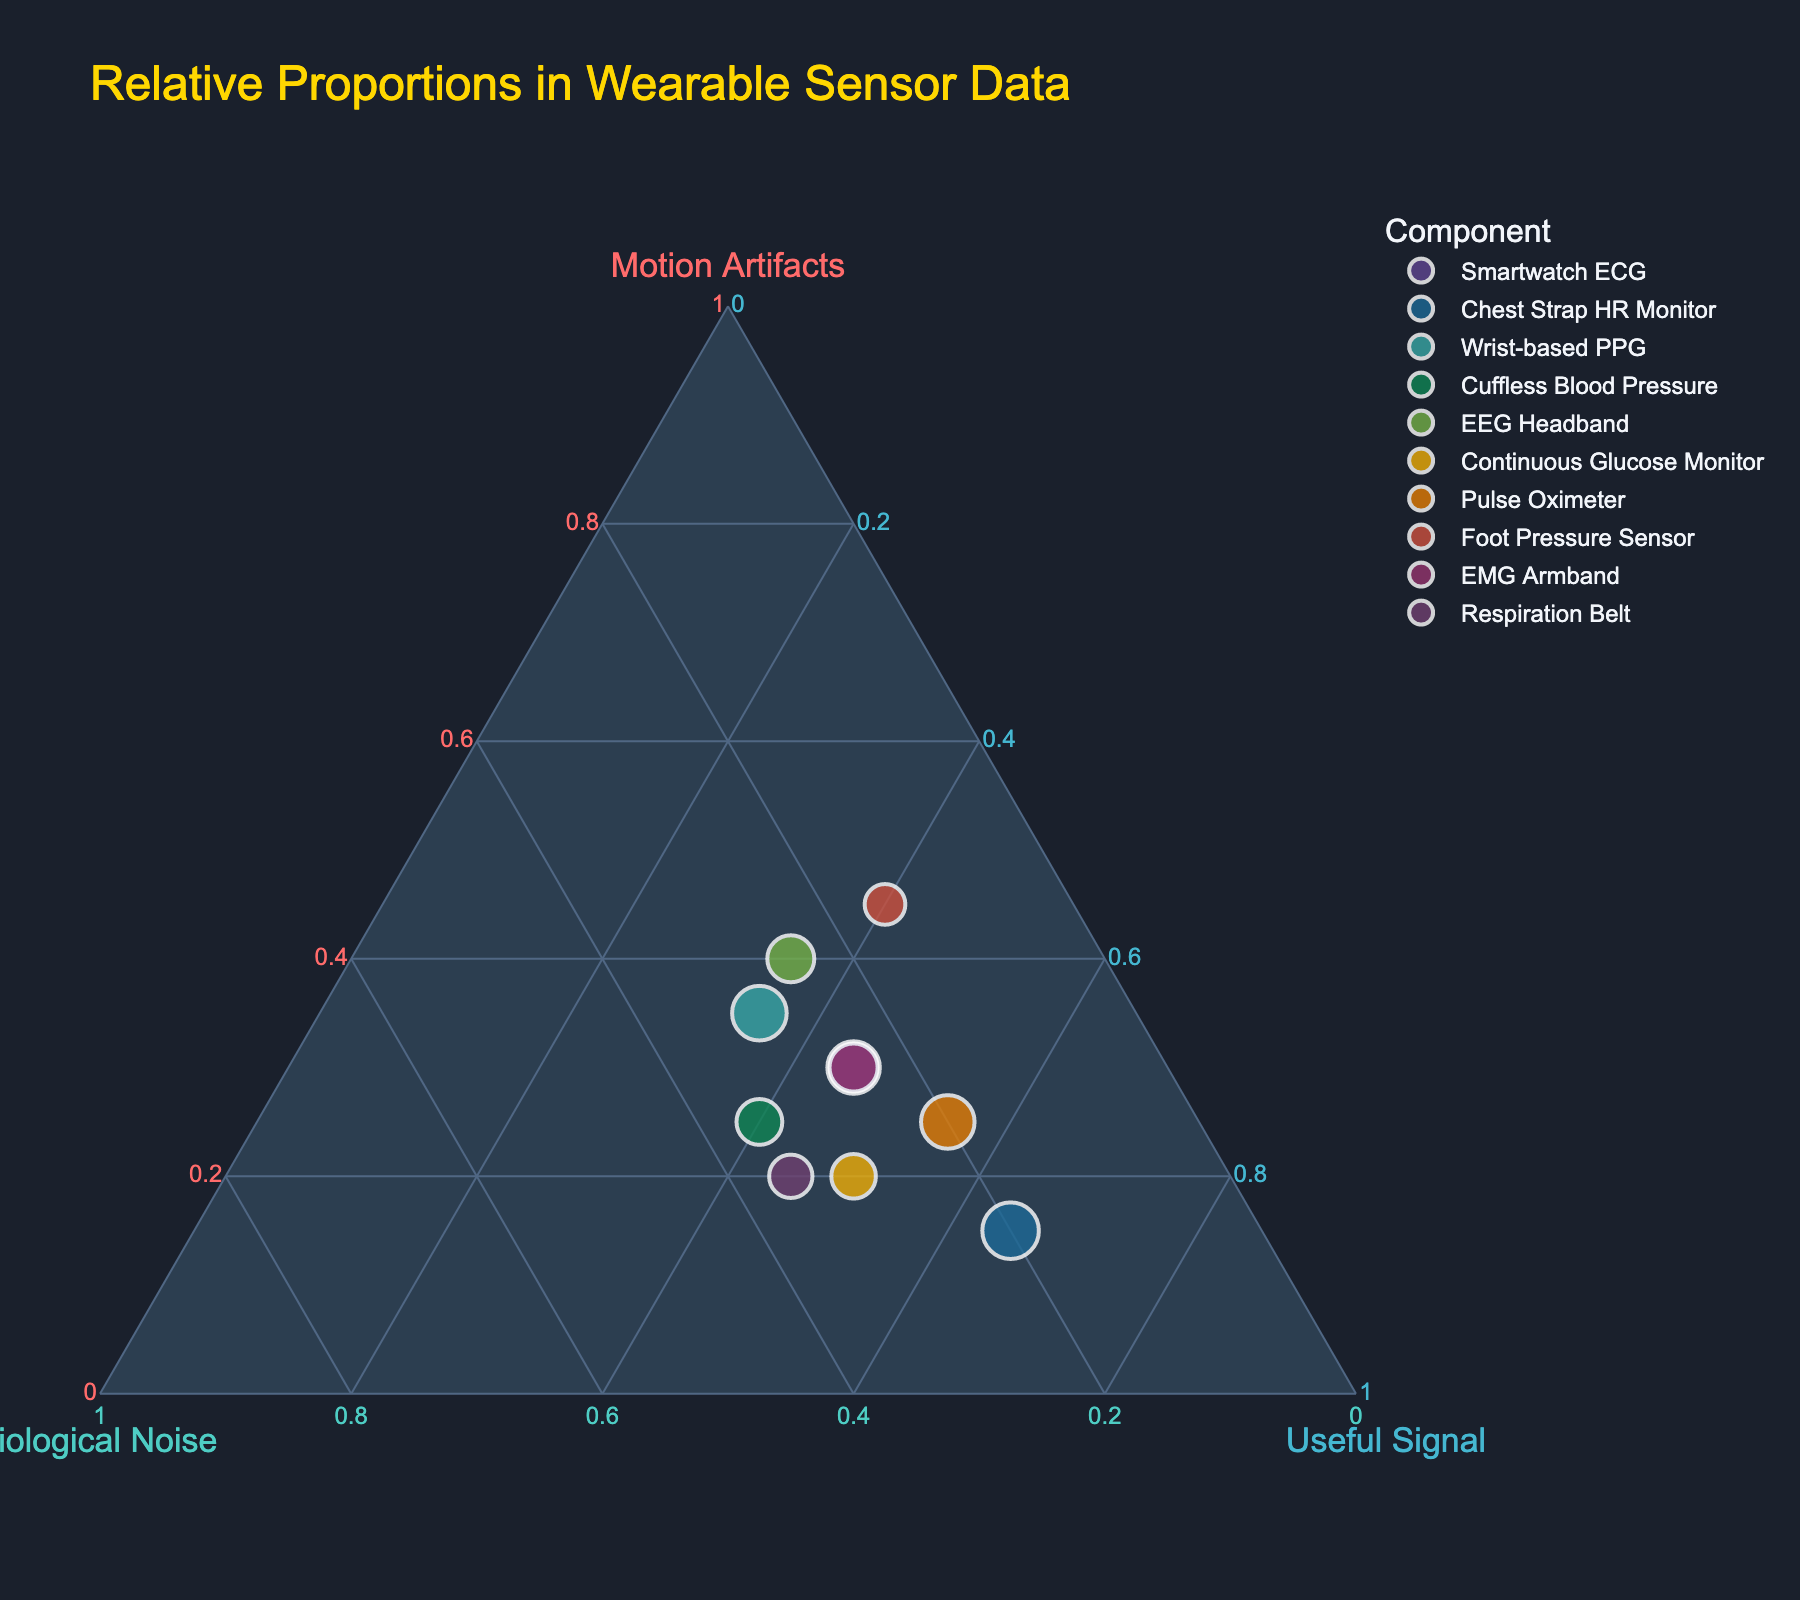what is the title of the figure? The title is usually displayed at the top of the figure and helps summarize the content. The title of this figure indicates it represents different proportions in wearable sensor data.
Answer: Relative Proportions in Wearable Sensor Data which component has the highest useful signal proportion? By examining the axis labeled "Useful Signal", we can identify the data point closest to the top of that axis, representing the maximum useful signal proportion.
Answer: Chest Strap HR Monitor how many data points have 'cuffless blood pressure' in their component name? Each unique component is represented as a distinct data point on the ternary plot. Identifying the number of occurrences of 'Cuffless Blood Pressure' involves counting these points.
Answer: One what is the sum of the motion artifacts proportions for the foot pressure sensor and emg armband? Look at the "Motion Artifacts" axis and find the values for 'Foot Pressure Sensor' and 'EMG Armband'. Sum these values (45 + 30).
Answer: 75 which sensor has more physiological noise: smartwatch ecg or respiratory belt? Compare the values on the "Physiological Noise" axis for 'Smartwatch ECG' and 'Respiratory Belt'. Identify the one with the higher value.
Answer: Respiration Belt which sensor has the most balanced proportions? A sensor with balanced proportions would have values relatively close to each other on all three axes. Examine the data points and identify the one with minimal variation among its three components.
Answer: Wrist-based PPG which components have a combination where motion artifacts are exactly 40? Identify the data points on the "Motion Artifacts" axis and reference the ones with a value of exactly 40.
Answer: EEG Headband what is the average useful signal proportion across all sensors? Sum the "Useful Signal" proportions for all sensors and divide by the number of components (45+65+35+40+35+50+55+40+45+45) / 10.
Answer: 45 which sensor has the largest bubble size in the plot? Look for the data point represented by the largest bubble in the figure. The size aspect is indicated by the notable diameter of the bubble.
Answer: Varies which sensor has the least physiological noise contribution and what is this contribution? Identify the data point closest to the bottom of the "Physiological Noise" axis, thus indicating the minimum physiological noise proportion.
Answer: Foot Pressure Sensor, 15 